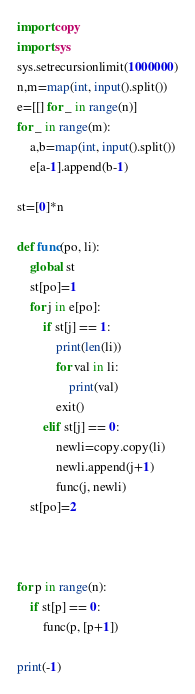Convert code to text. <code><loc_0><loc_0><loc_500><loc_500><_Python_>import copy
import sys
sys.setrecursionlimit(1000000)
n,m=map(int, input().split())
e=[[] for _ in range(n)]
for _ in range(m):
    a,b=map(int, input().split())
    e[a-1].append(b-1)

st=[0]*n

def func(po, li):
    global st
    st[po]=1
    for j in e[po]:
        if st[j] == 1:
            print(len(li))
            for val in li:
                print(val)
            exit()
        elif st[j] == 0:
            newli=copy.copy(li)
            newli.append(j+1)
            func(j, newli)
    st[po]=2
        


for p in range(n):
    if st[p] == 0:
        func(p, [p+1])

print(-1)
</code> 